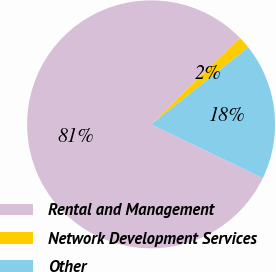Convert chart to OTSL. <chart><loc_0><loc_0><loc_500><loc_500><pie_chart><fcel>Rental and Management<fcel>Network Development Services<fcel>Other<nl><fcel>80.56%<fcel>1.63%<fcel>17.81%<nl></chart> 